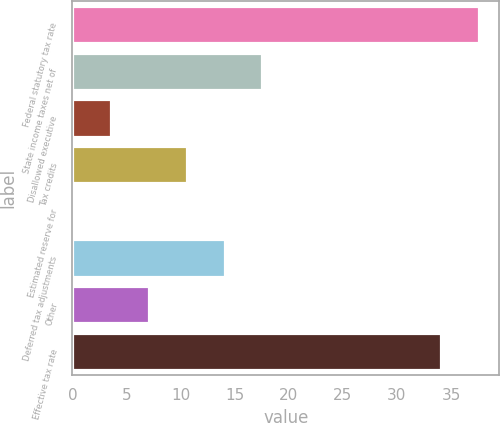Convert chart. <chart><loc_0><loc_0><loc_500><loc_500><bar_chart><fcel>Federal statutory tax rate<fcel>State income taxes net of<fcel>Disallowed executive<fcel>Tax credits<fcel>Estimated reserve for<fcel>Deferred tax adjustments<fcel>Other<fcel>Effective tax rate<nl><fcel>37.59<fcel>17.55<fcel>3.59<fcel>10.57<fcel>0.1<fcel>14.06<fcel>7.08<fcel>34.1<nl></chart> 